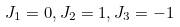<formula> <loc_0><loc_0><loc_500><loc_500>J _ { 1 } = 0 , J _ { 2 } = 1 , J _ { 3 } = - 1</formula> 